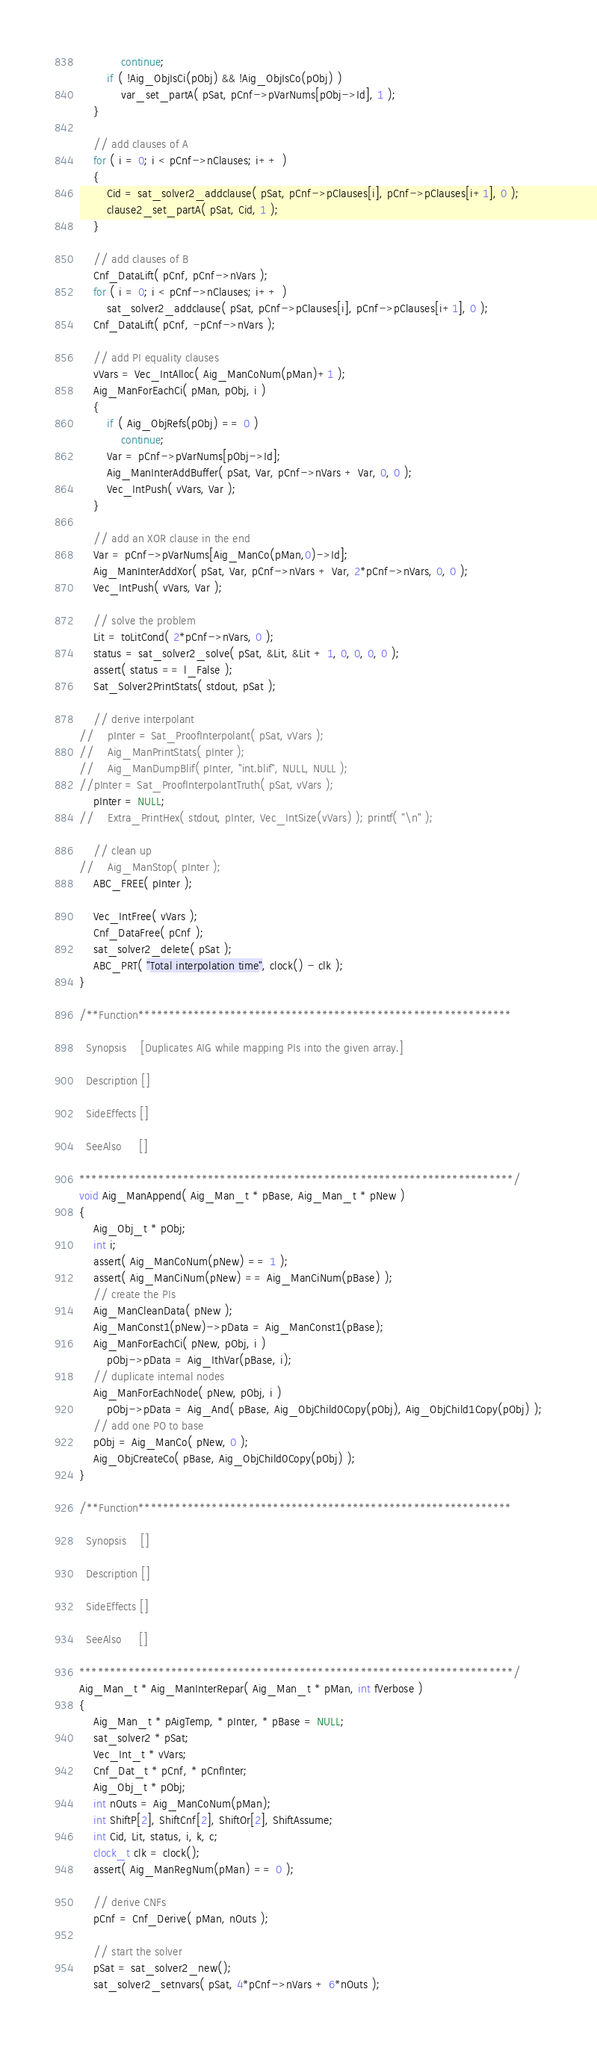Convert code to text. <code><loc_0><loc_0><loc_500><loc_500><_C_>            continue;
        if ( !Aig_ObjIsCi(pObj) && !Aig_ObjIsCo(pObj) )
            var_set_partA( pSat, pCnf->pVarNums[pObj->Id], 1 );
    }

    // add clauses of A
    for ( i = 0; i < pCnf->nClauses; i++ )
    {
        Cid = sat_solver2_addclause( pSat, pCnf->pClauses[i], pCnf->pClauses[i+1], 0 );
        clause2_set_partA( pSat, Cid, 1 );
    }

    // add clauses of B
    Cnf_DataLift( pCnf, pCnf->nVars );
    for ( i = 0; i < pCnf->nClauses; i++ )
        sat_solver2_addclause( pSat, pCnf->pClauses[i], pCnf->pClauses[i+1], 0 );
    Cnf_DataLift( pCnf, -pCnf->nVars );

    // add PI equality clauses
    vVars = Vec_IntAlloc( Aig_ManCoNum(pMan)+1 );
    Aig_ManForEachCi( pMan, pObj, i )
    {
        if ( Aig_ObjRefs(pObj) == 0 )
            continue;
        Var = pCnf->pVarNums[pObj->Id];
        Aig_ManInterAddBuffer( pSat, Var, pCnf->nVars + Var, 0, 0 );
        Vec_IntPush( vVars, Var );
    }

    // add an XOR clause in the end
    Var = pCnf->pVarNums[Aig_ManCo(pMan,0)->Id];
    Aig_ManInterAddXor( pSat, Var, pCnf->nVars + Var, 2*pCnf->nVars, 0, 0 );
    Vec_IntPush( vVars, Var );

    // solve the problem
    Lit = toLitCond( 2*pCnf->nVars, 0 );
    status = sat_solver2_solve( pSat, &Lit, &Lit + 1, 0, 0, 0, 0 );
    assert( status == l_False );
    Sat_Solver2PrintStats( stdout, pSat );

    // derive interpolant
//    pInter = Sat_ProofInterpolant( pSat, vVars );
//    Aig_ManPrintStats( pInter );
//    Aig_ManDumpBlif( pInter, "int.blif", NULL, NULL );
//pInter = Sat_ProofInterpolantTruth( pSat, vVars );
    pInter = NULL;
//    Extra_PrintHex( stdout, pInter, Vec_IntSize(vVars) ); printf( "\n" );

    // clean up
//    Aig_ManStop( pInter );
    ABC_FREE( pInter );

    Vec_IntFree( vVars );
    Cnf_DataFree( pCnf );
    sat_solver2_delete( pSat );
    ABC_PRT( "Total interpolation time", clock() - clk );
}

/**Function*************************************************************

  Synopsis    [Duplicates AIG while mapping PIs into the given array.]

  Description []
               
  SideEffects []

  SeeAlso     []

***********************************************************************/
void Aig_ManAppend( Aig_Man_t * pBase, Aig_Man_t * pNew )
{
    Aig_Obj_t * pObj;
    int i;
    assert( Aig_ManCoNum(pNew) == 1 );
    assert( Aig_ManCiNum(pNew) == Aig_ManCiNum(pBase) );
    // create the PIs
    Aig_ManCleanData( pNew );
    Aig_ManConst1(pNew)->pData = Aig_ManConst1(pBase);
    Aig_ManForEachCi( pNew, pObj, i )
        pObj->pData = Aig_IthVar(pBase, i);
    // duplicate internal nodes
    Aig_ManForEachNode( pNew, pObj, i )
        pObj->pData = Aig_And( pBase, Aig_ObjChild0Copy(pObj), Aig_ObjChild1Copy(pObj) );
    // add one PO to base
    pObj = Aig_ManCo( pNew, 0 );
    Aig_ObjCreateCo( pBase, Aig_ObjChild0Copy(pObj) );
}

/**Function*************************************************************

  Synopsis    []

  Description []
               
  SideEffects []

  SeeAlso     []

***********************************************************************/
Aig_Man_t * Aig_ManInterRepar( Aig_Man_t * pMan, int fVerbose )
{
    Aig_Man_t * pAigTemp, * pInter, * pBase = NULL;
    sat_solver2 * pSat;
    Vec_Int_t * vVars;
    Cnf_Dat_t * pCnf, * pCnfInter;
    Aig_Obj_t * pObj;
    int nOuts = Aig_ManCoNum(pMan);
    int ShiftP[2], ShiftCnf[2], ShiftOr[2], ShiftAssume;
    int Cid, Lit, status, i, k, c;
    clock_t clk = clock();
    assert( Aig_ManRegNum(pMan) == 0 );

    // derive CNFs
    pCnf = Cnf_Derive( pMan, nOuts );

    // start the solver
    pSat = sat_solver2_new();
    sat_solver2_setnvars( pSat, 4*pCnf->nVars + 6*nOuts );</code> 